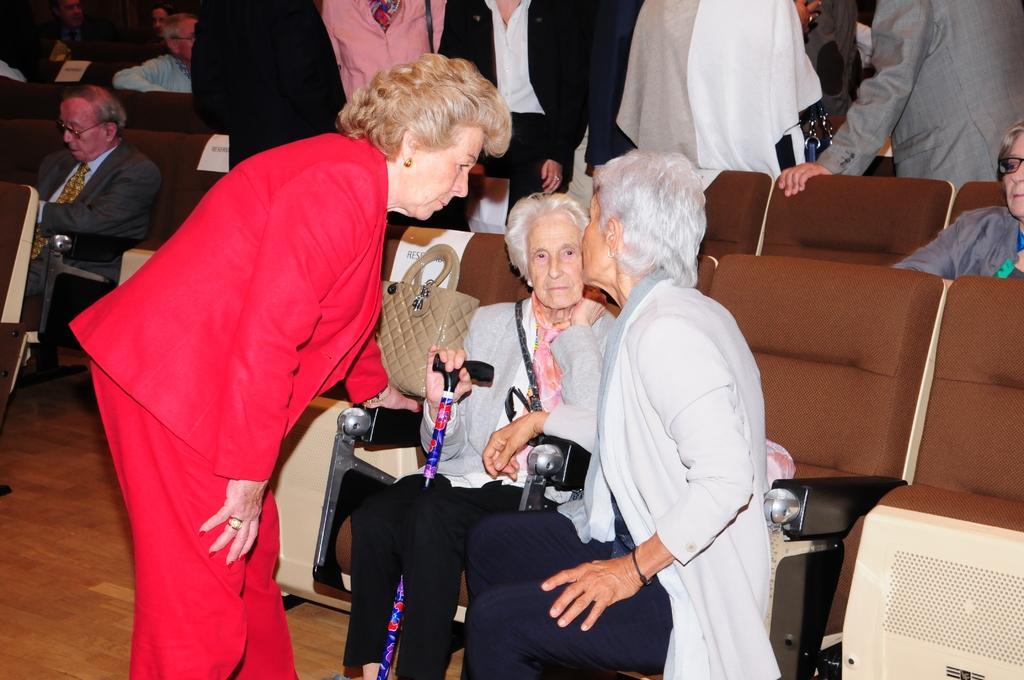How would you summarize this image in a sentence or two? In this image I can see group of people some are sitting and some are standing. The person in front wearing gray color jacket and blue pant, and the person at left wearing red color dress. Background I can see few other persons standing. 